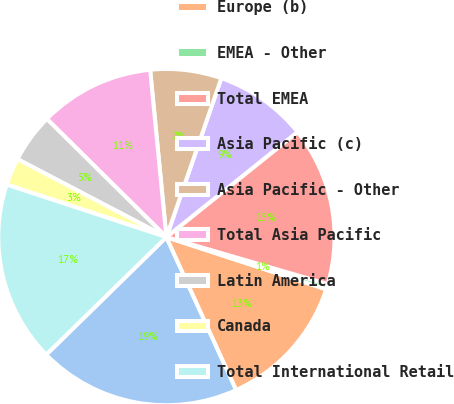Convert chart. <chart><loc_0><loc_0><loc_500><loc_500><pie_chart><fcel>United States<fcel>Europe (b)<fcel>EMEA - Other<fcel>Total EMEA<fcel>Asia Pacific (c)<fcel>Asia Pacific - Other<fcel>Total Asia Pacific<fcel>Latin America<fcel>Canada<fcel>Total International Retail<nl><fcel>19.49%<fcel>13.16%<fcel>0.51%<fcel>15.27%<fcel>8.95%<fcel>6.84%<fcel>11.05%<fcel>4.73%<fcel>2.62%<fcel>17.38%<nl></chart> 